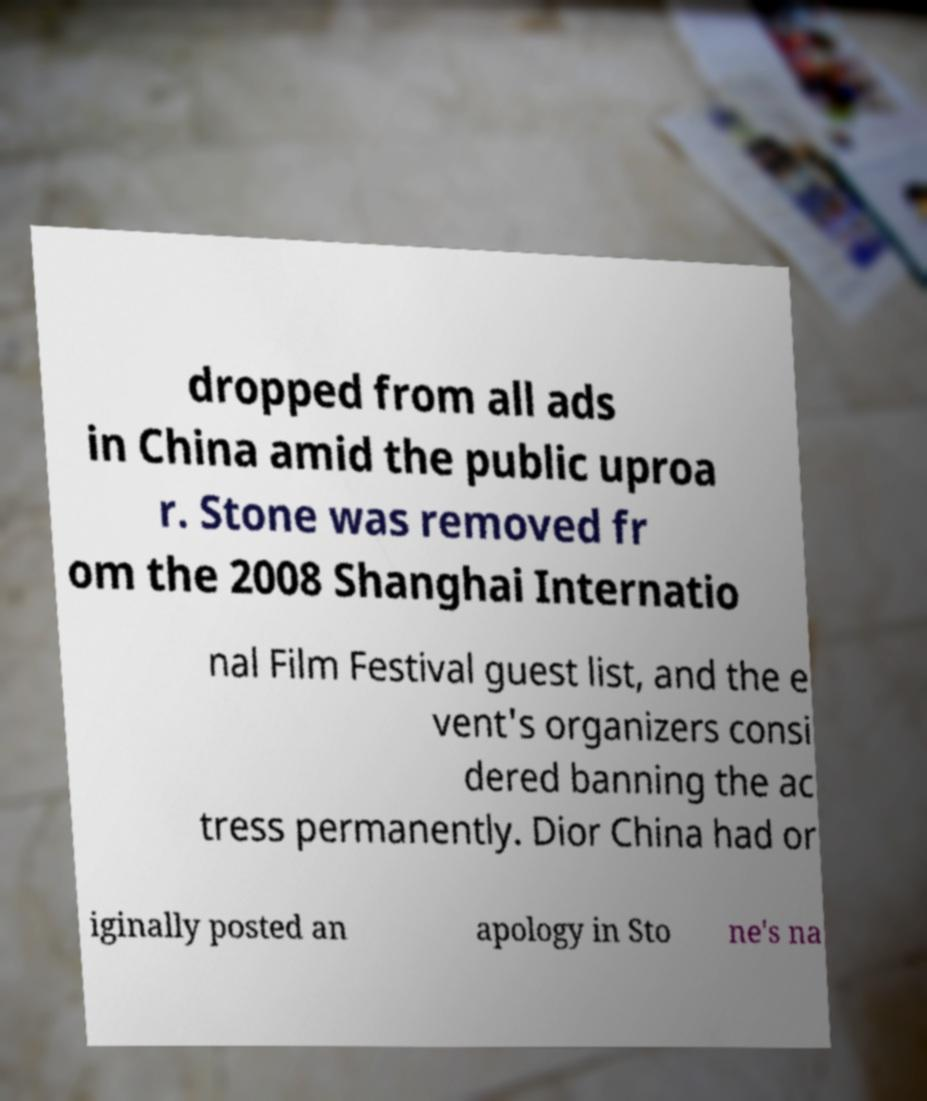What messages or text are displayed in this image? I need them in a readable, typed format. dropped from all ads in China amid the public uproa r. Stone was removed fr om the 2008 Shanghai Internatio nal Film Festival guest list, and the e vent's organizers consi dered banning the ac tress permanently. Dior China had or iginally posted an apology in Sto ne's na 